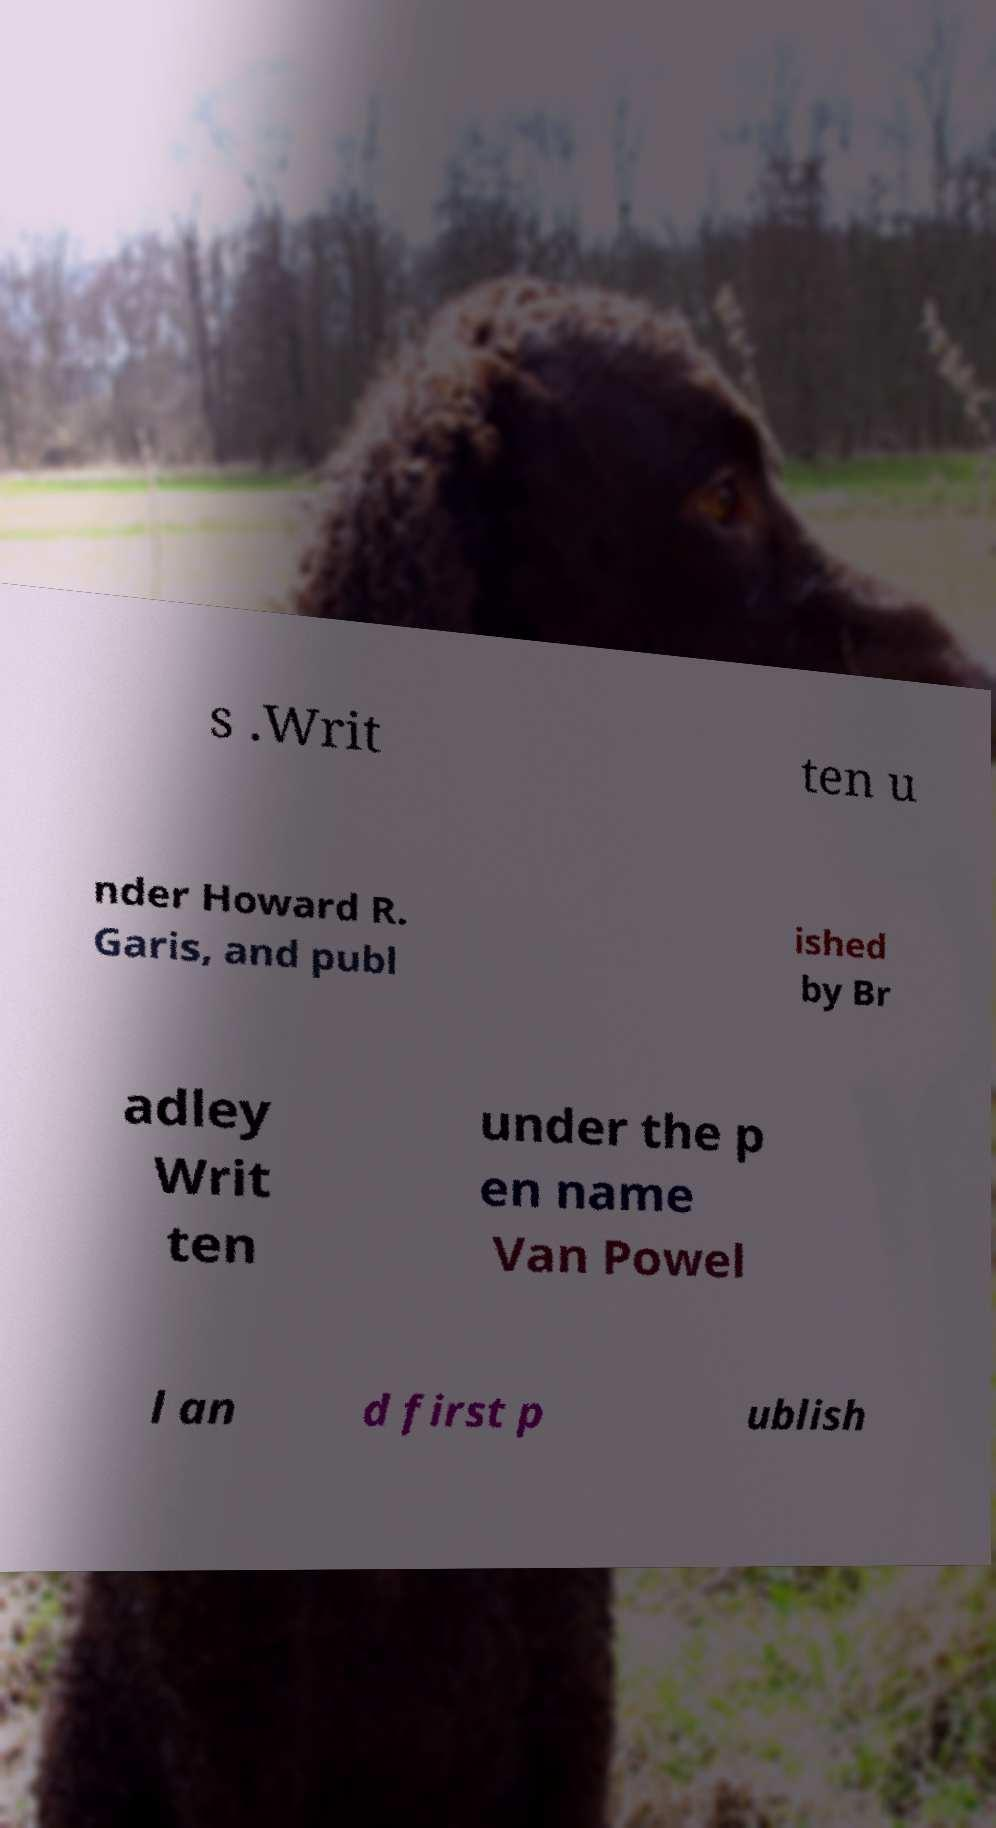I need the written content from this picture converted into text. Can you do that? s .Writ ten u nder Howard R. Garis, and publ ished by Br adley Writ ten under the p en name Van Powel l an d first p ublish 